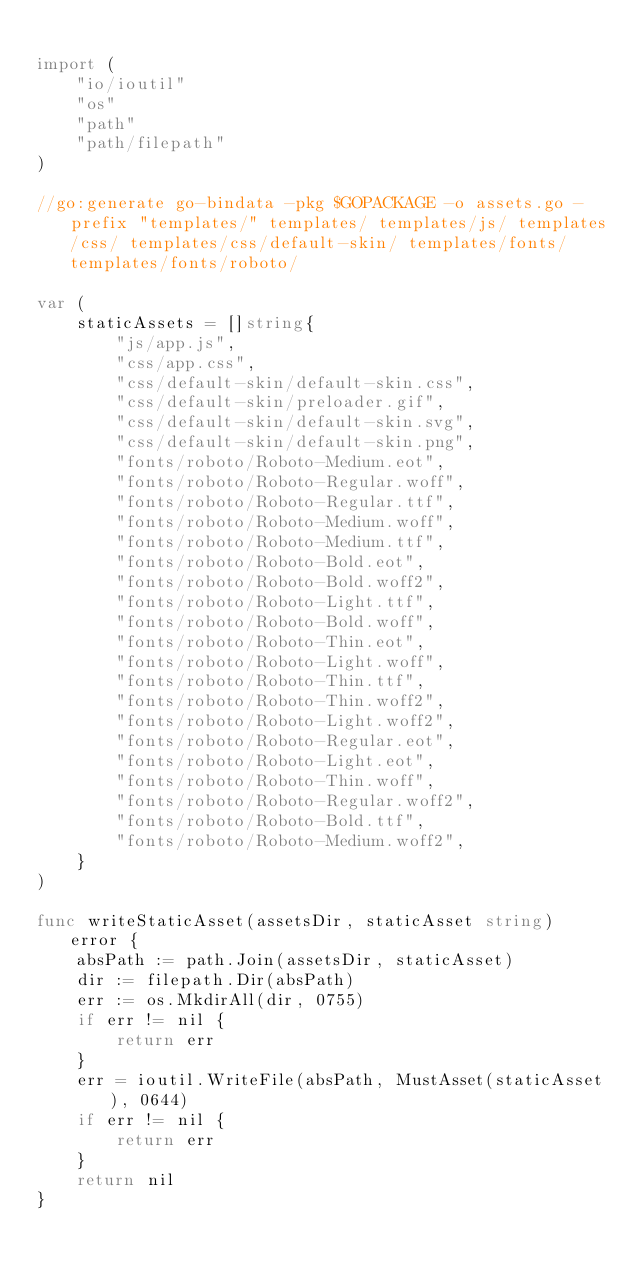<code> <loc_0><loc_0><loc_500><loc_500><_Go_>
import (
	"io/ioutil"
	"os"
	"path"
	"path/filepath"
)

//go:generate go-bindata -pkg $GOPACKAGE -o assets.go -prefix "templates/" templates/ templates/js/ templates/css/ templates/css/default-skin/ templates/fonts/ templates/fonts/roboto/

var (
	staticAssets = []string{
		"js/app.js",
		"css/app.css",
		"css/default-skin/default-skin.css",
		"css/default-skin/preloader.gif",
		"css/default-skin/default-skin.svg",
		"css/default-skin/default-skin.png",
		"fonts/roboto/Roboto-Medium.eot",
		"fonts/roboto/Roboto-Regular.woff",
		"fonts/roboto/Roboto-Regular.ttf",
		"fonts/roboto/Roboto-Medium.woff",
		"fonts/roboto/Roboto-Medium.ttf",
		"fonts/roboto/Roboto-Bold.eot",
		"fonts/roboto/Roboto-Bold.woff2",
		"fonts/roboto/Roboto-Light.ttf",
		"fonts/roboto/Roboto-Bold.woff",
		"fonts/roboto/Roboto-Thin.eot",
		"fonts/roboto/Roboto-Light.woff",
		"fonts/roboto/Roboto-Thin.ttf",
		"fonts/roboto/Roboto-Thin.woff2",
		"fonts/roboto/Roboto-Light.woff2",
		"fonts/roboto/Roboto-Regular.eot",
		"fonts/roboto/Roboto-Light.eot",
		"fonts/roboto/Roboto-Thin.woff",
		"fonts/roboto/Roboto-Regular.woff2",
		"fonts/roboto/Roboto-Bold.ttf",
		"fonts/roboto/Roboto-Medium.woff2",
	}
)

func writeStaticAsset(assetsDir, staticAsset string) error {
	absPath := path.Join(assetsDir, staticAsset)
	dir := filepath.Dir(absPath)
	err := os.MkdirAll(dir, 0755)
	if err != nil {
		return err
	}
	err = ioutil.WriteFile(absPath, MustAsset(staticAsset), 0644)
	if err != nil {
		return err
	}
	return nil
}
</code> 